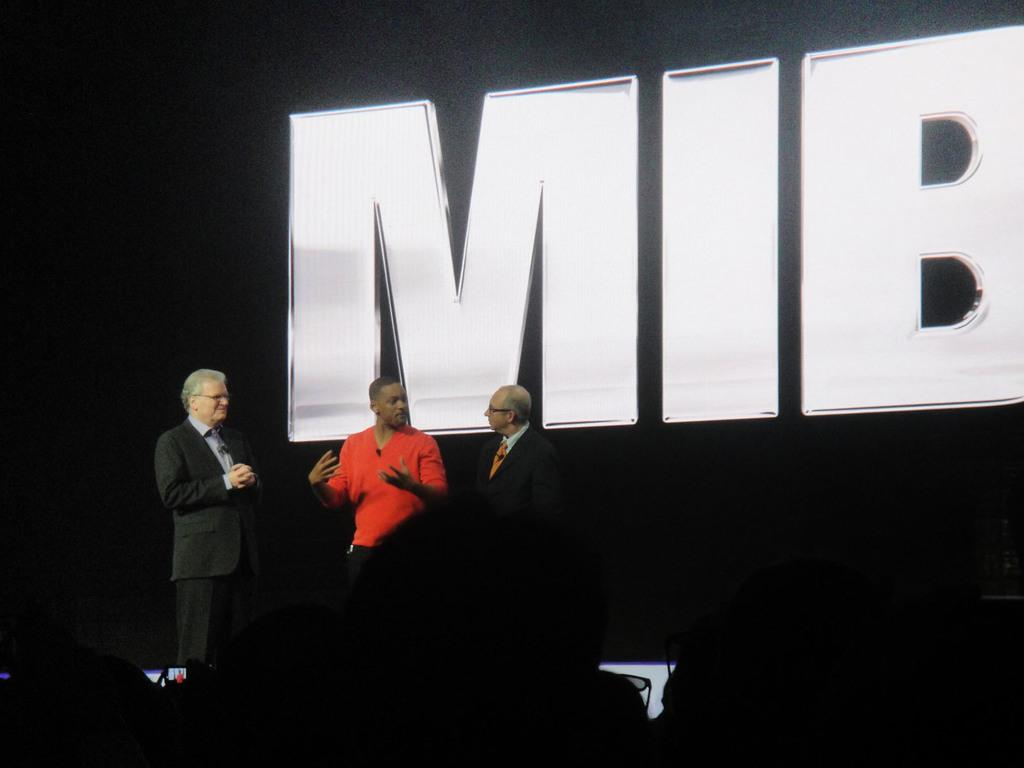How many people are in the image? There are people in the image, but the exact number is not specified. What type of clothing can be seen on some of the people? Some people are wearing coats and ties. What can be seen on a screen in the background of the image? There is text visible on a screen in the background of the image. What type of floor can be seen in the image? There is no information about the floor in the image. Can you describe the stamp on the tie of the person in the image? There is no mention of a stamp on any tie in the image. 